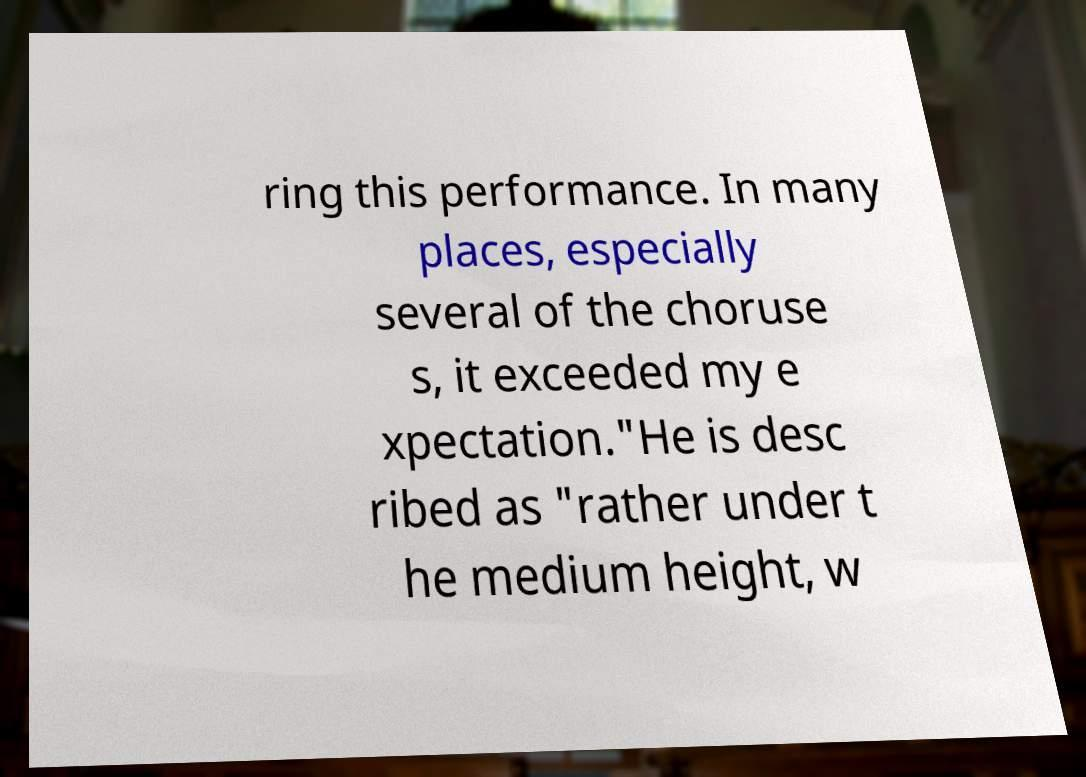What messages or text are displayed in this image? I need them in a readable, typed format. ring this performance. In many places, especially several of the choruse s, it exceeded my e xpectation."He is desc ribed as "rather under t he medium height, w 